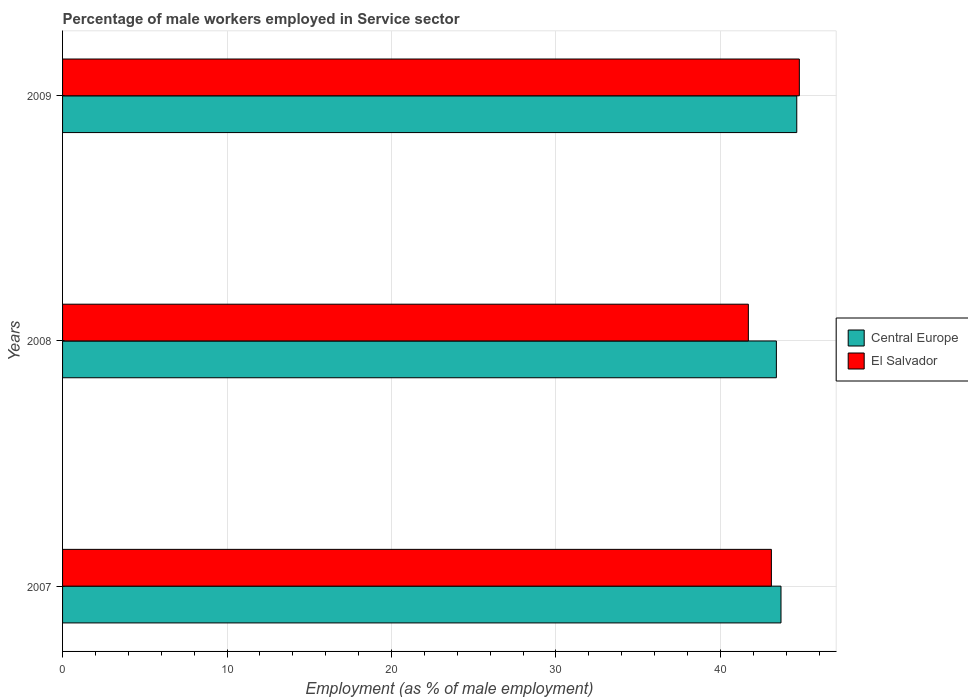How many different coloured bars are there?
Give a very brief answer. 2. Are the number of bars on each tick of the Y-axis equal?
Make the answer very short. Yes. What is the percentage of male workers employed in Service sector in El Salvador in 2008?
Provide a succinct answer. 41.7. Across all years, what is the maximum percentage of male workers employed in Service sector in El Salvador?
Keep it short and to the point. 44.8. Across all years, what is the minimum percentage of male workers employed in Service sector in Central Europe?
Offer a terse response. 43.4. In which year was the percentage of male workers employed in Service sector in El Salvador minimum?
Keep it short and to the point. 2008. What is the total percentage of male workers employed in Service sector in El Salvador in the graph?
Offer a very short reply. 129.6. What is the difference between the percentage of male workers employed in Service sector in El Salvador in 2008 and that in 2009?
Keep it short and to the point. -3.1. What is the difference between the percentage of male workers employed in Service sector in Central Europe in 2008 and the percentage of male workers employed in Service sector in El Salvador in 2007?
Your answer should be very brief. 0.3. What is the average percentage of male workers employed in Service sector in El Salvador per year?
Your answer should be compact. 43.2. In the year 2007, what is the difference between the percentage of male workers employed in Service sector in Central Europe and percentage of male workers employed in Service sector in El Salvador?
Make the answer very short. 0.58. What is the ratio of the percentage of male workers employed in Service sector in Central Europe in 2007 to that in 2009?
Give a very brief answer. 0.98. What is the difference between the highest and the second highest percentage of male workers employed in Service sector in El Salvador?
Provide a short and direct response. 1.7. What is the difference between the highest and the lowest percentage of male workers employed in Service sector in Central Europe?
Offer a very short reply. 1.24. In how many years, is the percentage of male workers employed in Service sector in El Salvador greater than the average percentage of male workers employed in Service sector in El Salvador taken over all years?
Your answer should be compact. 1. Is the sum of the percentage of male workers employed in Service sector in El Salvador in 2007 and 2008 greater than the maximum percentage of male workers employed in Service sector in Central Europe across all years?
Keep it short and to the point. Yes. What does the 2nd bar from the top in 2007 represents?
Offer a terse response. Central Europe. What does the 1st bar from the bottom in 2009 represents?
Your answer should be very brief. Central Europe. How many bars are there?
Offer a terse response. 6. Are all the bars in the graph horizontal?
Give a very brief answer. Yes. How many years are there in the graph?
Make the answer very short. 3. Does the graph contain grids?
Provide a short and direct response. Yes. Where does the legend appear in the graph?
Your response must be concise. Center right. How many legend labels are there?
Your answer should be compact. 2. What is the title of the graph?
Offer a very short reply. Percentage of male workers employed in Service sector. Does "Brazil" appear as one of the legend labels in the graph?
Keep it short and to the point. No. What is the label or title of the X-axis?
Offer a very short reply. Employment (as % of male employment). What is the label or title of the Y-axis?
Ensure brevity in your answer.  Years. What is the Employment (as % of male employment) of Central Europe in 2007?
Make the answer very short. 43.68. What is the Employment (as % of male employment) in El Salvador in 2007?
Give a very brief answer. 43.1. What is the Employment (as % of male employment) in Central Europe in 2008?
Provide a succinct answer. 43.4. What is the Employment (as % of male employment) of El Salvador in 2008?
Your answer should be compact. 41.7. What is the Employment (as % of male employment) of Central Europe in 2009?
Make the answer very short. 44.64. What is the Employment (as % of male employment) of El Salvador in 2009?
Your answer should be compact. 44.8. Across all years, what is the maximum Employment (as % of male employment) in Central Europe?
Provide a short and direct response. 44.64. Across all years, what is the maximum Employment (as % of male employment) in El Salvador?
Your response must be concise. 44.8. Across all years, what is the minimum Employment (as % of male employment) of Central Europe?
Offer a very short reply. 43.4. Across all years, what is the minimum Employment (as % of male employment) of El Salvador?
Ensure brevity in your answer.  41.7. What is the total Employment (as % of male employment) in Central Europe in the graph?
Your response must be concise. 131.73. What is the total Employment (as % of male employment) of El Salvador in the graph?
Give a very brief answer. 129.6. What is the difference between the Employment (as % of male employment) in Central Europe in 2007 and that in 2008?
Offer a terse response. 0.28. What is the difference between the Employment (as % of male employment) in Central Europe in 2007 and that in 2009?
Keep it short and to the point. -0.96. What is the difference between the Employment (as % of male employment) in El Salvador in 2007 and that in 2009?
Provide a succinct answer. -1.7. What is the difference between the Employment (as % of male employment) of Central Europe in 2008 and that in 2009?
Ensure brevity in your answer.  -1.24. What is the difference between the Employment (as % of male employment) in El Salvador in 2008 and that in 2009?
Your answer should be compact. -3.1. What is the difference between the Employment (as % of male employment) in Central Europe in 2007 and the Employment (as % of male employment) in El Salvador in 2008?
Provide a succinct answer. 1.98. What is the difference between the Employment (as % of male employment) in Central Europe in 2007 and the Employment (as % of male employment) in El Salvador in 2009?
Provide a short and direct response. -1.12. What is the difference between the Employment (as % of male employment) in Central Europe in 2008 and the Employment (as % of male employment) in El Salvador in 2009?
Offer a very short reply. -1.4. What is the average Employment (as % of male employment) in Central Europe per year?
Offer a very short reply. 43.91. What is the average Employment (as % of male employment) in El Salvador per year?
Your response must be concise. 43.2. In the year 2007, what is the difference between the Employment (as % of male employment) of Central Europe and Employment (as % of male employment) of El Salvador?
Your response must be concise. 0.58. In the year 2008, what is the difference between the Employment (as % of male employment) in Central Europe and Employment (as % of male employment) in El Salvador?
Keep it short and to the point. 1.7. In the year 2009, what is the difference between the Employment (as % of male employment) of Central Europe and Employment (as % of male employment) of El Salvador?
Your response must be concise. -0.16. What is the ratio of the Employment (as % of male employment) in Central Europe in 2007 to that in 2008?
Your response must be concise. 1.01. What is the ratio of the Employment (as % of male employment) of El Salvador in 2007 to that in 2008?
Offer a very short reply. 1.03. What is the ratio of the Employment (as % of male employment) in Central Europe in 2007 to that in 2009?
Provide a succinct answer. 0.98. What is the ratio of the Employment (as % of male employment) in El Salvador in 2007 to that in 2009?
Your answer should be very brief. 0.96. What is the ratio of the Employment (as % of male employment) of Central Europe in 2008 to that in 2009?
Your answer should be very brief. 0.97. What is the ratio of the Employment (as % of male employment) of El Salvador in 2008 to that in 2009?
Make the answer very short. 0.93. What is the difference between the highest and the second highest Employment (as % of male employment) of Central Europe?
Provide a succinct answer. 0.96. What is the difference between the highest and the second highest Employment (as % of male employment) in El Salvador?
Make the answer very short. 1.7. What is the difference between the highest and the lowest Employment (as % of male employment) in Central Europe?
Keep it short and to the point. 1.24. What is the difference between the highest and the lowest Employment (as % of male employment) in El Salvador?
Provide a succinct answer. 3.1. 